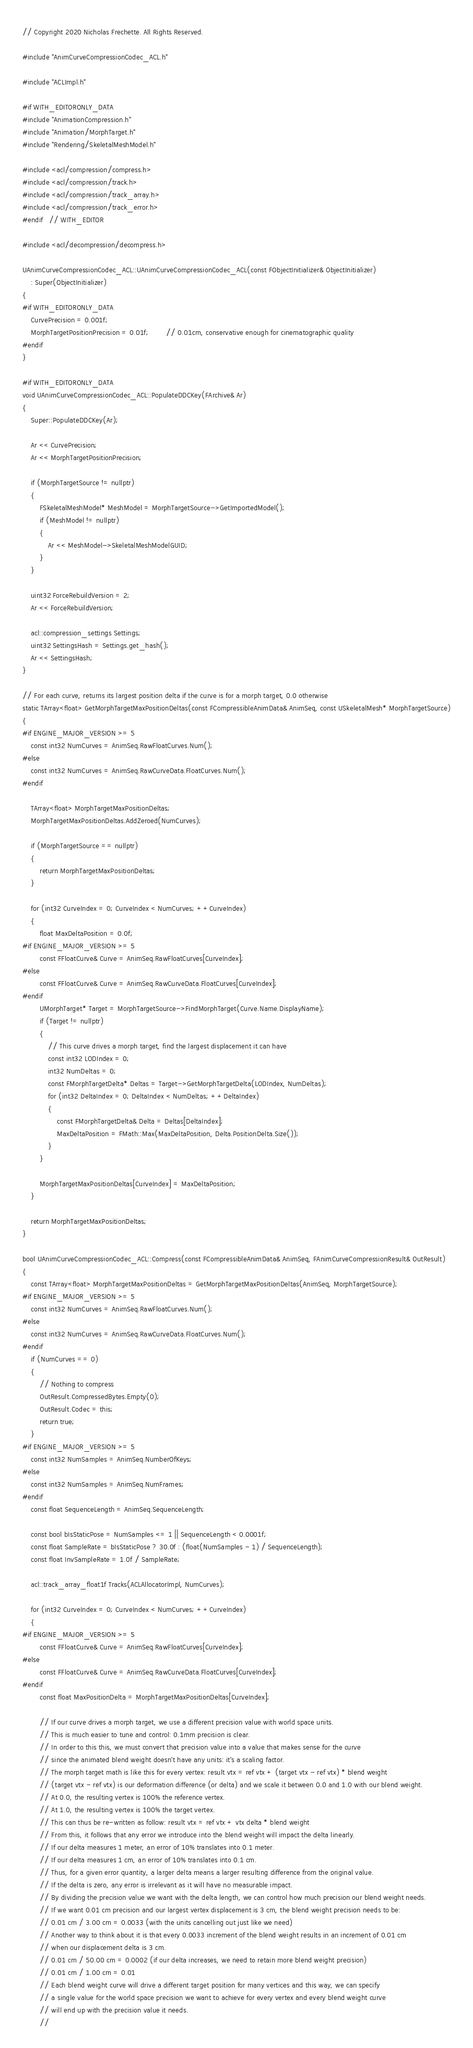<code> <loc_0><loc_0><loc_500><loc_500><_C++_>// Copyright 2020 Nicholas Frechette. All Rights Reserved.

#include "AnimCurveCompressionCodec_ACL.h"

#include "ACLImpl.h"

#if WITH_EDITORONLY_DATA
#include "AnimationCompression.h"
#include "Animation/MorphTarget.h"
#include "Rendering/SkeletalMeshModel.h"

#include <acl/compression/compress.h>
#include <acl/compression/track.h>
#include <acl/compression/track_array.h>
#include <acl/compression/track_error.h>
#endif	// WITH_EDITOR

#include <acl/decompression/decompress.h>

UAnimCurveCompressionCodec_ACL::UAnimCurveCompressionCodec_ACL(const FObjectInitializer& ObjectInitializer)
	: Super(ObjectInitializer)
{
#if WITH_EDITORONLY_DATA
	CurvePrecision = 0.001f;
	MorphTargetPositionPrecision = 0.01f;		// 0.01cm, conservative enough for cinematographic quality
#endif
}

#if WITH_EDITORONLY_DATA
void UAnimCurveCompressionCodec_ACL::PopulateDDCKey(FArchive& Ar)
{
	Super::PopulateDDCKey(Ar);

	Ar << CurvePrecision;
	Ar << MorphTargetPositionPrecision;

	if (MorphTargetSource != nullptr)
	{
		FSkeletalMeshModel* MeshModel = MorphTargetSource->GetImportedModel();
		if (MeshModel != nullptr)
		{
			Ar << MeshModel->SkeletalMeshModelGUID;
		}
	}

	uint32 ForceRebuildVersion = 2;
	Ar << ForceRebuildVersion;

	acl::compression_settings Settings;
	uint32 SettingsHash = Settings.get_hash();
	Ar << SettingsHash;
}

// For each curve, returns its largest position delta if the curve is for a morph target, 0.0 otherwise
static TArray<float> GetMorphTargetMaxPositionDeltas(const FCompressibleAnimData& AnimSeq, const USkeletalMesh* MorphTargetSource)
{
#if ENGINE_MAJOR_VERSION >= 5
	const int32 NumCurves = AnimSeq.RawFloatCurves.Num();
#else
	const int32 NumCurves = AnimSeq.RawCurveData.FloatCurves.Num();
#endif

	TArray<float> MorphTargetMaxPositionDeltas;
	MorphTargetMaxPositionDeltas.AddZeroed(NumCurves);

	if (MorphTargetSource == nullptr)
	{
		return MorphTargetMaxPositionDeltas;
	}

	for (int32 CurveIndex = 0; CurveIndex < NumCurves; ++CurveIndex)
	{
		float MaxDeltaPosition = 0.0f;
#if ENGINE_MAJOR_VERSION >= 5
		const FFloatCurve& Curve = AnimSeq.RawFloatCurves[CurveIndex];
#else
		const FFloatCurve& Curve = AnimSeq.RawCurveData.FloatCurves[CurveIndex];
#endif
		UMorphTarget* Target = MorphTargetSource->FindMorphTarget(Curve.Name.DisplayName);
		if (Target != nullptr)
		{
			// This curve drives a morph target, find the largest displacement it can have
			const int32 LODIndex = 0;
			int32 NumDeltas = 0;
			const FMorphTargetDelta* Deltas = Target->GetMorphTargetDelta(LODIndex, NumDeltas);
			for (int32 DeltaIndex = 0; DeltaIndex < NumDeltas; ++DeltaIndex)
			{
				const FMorphTargetDelta& Delta = Deltas[DeltaIndex];
				MaxDeltaPosition = FMath::Max(MaxDeltaPosition, Delta.PositionDelta.Size());
			}
		}

		MorphTargetMaxPositionDeltas[CurveIndex] = MaxDeltaPosition;
	}

	return MorphTargetMaxPositionDeltas;
}

bool UAnimCurveCompressionCodec_ACL::Compress(const FCompressibleAnimData& AnimSeq, FAnimCurveCompressionResult& OutResult)
{
	const TArray<float> MorphTargetMaxPositionDeltas = GetMorphTargetMaxPositionDeltas(AnimSeq, MorphTargetSource);
#if ENGINE_MAJOR_VERSION >= 5
	const int32 NumCurves = AnimSeq.RawFloatCurves.Num();
#else
	const int32 NumCurves = AnimSeq.RawCurveData.FloatCurves.Num();
#endif
	if (NumCurves == 0)
	{
		// Nothing to compress
		OutResult.CompressedBytes.Empty(0);
		OutResult.Codec = this;
		return true;
	}
#if ENGINE_MAJOR_VERSION >= 5
	const int32 NumSamples = AnimSeq.NumberOfKeys;
#else
	const int32 NumSamples = AnimSeq.NumFrames;
#endif
	const float SequenceLength = AnimSeq.SequenceLength;

	const bool bIsStaticPose = NumSamples <= 1 || SequenceLength < 0.0001f;
	const float SampleRate = bIsStaticPose ? 30.0f : (float(NumSamples - 1) / SequenceLength);
	const float InvSampleRate = 1.0f / SampleRate;

	acl::track_array_float1f Tracks(ACLAllocatorImpl, NumCurves);

	for (int32 CurveIndex = 0; CurveIndex < NumCurves; ++CurveIndex)
	{
#if ENGINE_MAJOR_VERSION >= 5
		const FFloatCurve& Curve = AnimSeq.RawFloatCurves[CurveIndex];
#else
		const FFloatCurve& Curve = AnimSeq.RawCurveData.FloatCurves[CurveIndex];
#endif
		const float MaxPositionDelta = MorphTargetMaxPositionDeltas[CurveIndex];

		// If our curve drives a morph target, we use a different precision value with world space units.
		// This is much easier to tune and control: 0.1mm precision is clear.
		// In order to this this, we must convert that precision value into a value that makes sense for the curve
		// since the animated blend weight doesn't have any units: it's a scaling factor.
		// The morph target math is like this for every vertex: result vtx = ref vtx + (target vtx - ref vtx) * blend weight
		// (target vtx - ref vtx) is our deformation difference (or delta) and we scale it between 0.0 and 1.0 with our blend weight.
		// At 0.0, the resulting vertex is 100% the reference vertex.
		// At 1.0, the resulting vertex is 100% the target vertex.
		// This can thus be re-written as follow: result vtx = ref vtx + vtx delta * blend weight
		// From this, it follows that any error we introduce into the blend weight will impact the delta linearly.
		// If our delta measures 1 meter, an error of 10% translates into 0.1 meter.
		// If our delta measures 1 cm, an error of 10% translates into 0.1 cm.
		// Thus, for a given error quantity, a larger delta means a larger resulting difference from the original value.
		// If the delta is zero, any error is irrelevant as it will have no measurable impact.
		// By dividing the precision value we want with the delta length, we can control how much precision our blend weight needs.
		// If we want 0.01 cm precision and our largest vertex displacement is 3 cm, the blend weight precision needs to be:
		// 0.01 cm / 3.00 cm = 0.0033 (with the units cancelling out just like we need)
		// Another way to think about it is that every 0.0033 increment of the blend weight results in an increment of 0.01 cm
		// when our displacement delta is 3 cm.
		// 0.01 cm / 50.00 cm = 0.0002 (if our delta increases, we need to retain more blend weight precision)
		// 0.01 cm / 1.00 cm = 0.01
		// Each blend weight curve will drive a different target position for many vertices and this way, we can specify
		// a single value for the world space precision we want to achieve for every vertex and every blend weight curve
		// will end up with the precision value it needs.
		//</code> 